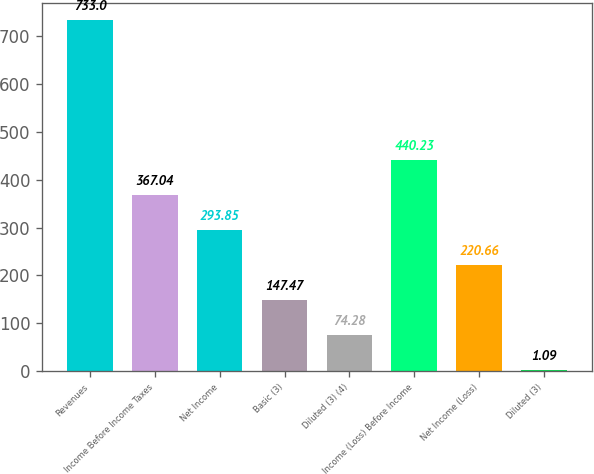Convert chart. <chart><loc_0><loc_0><loc_500><loc_500><bar_chart><fcel>Revenues<fcel>Income Before Income Taxes<fcel>Net Income<fcel>Basic (3)<fcel>Diluted (3) (4)<fcel>Income (Loss) Before Income<fcel>Net Income (Loss)<fcel>Diluted (3)<nl><fcel>733<fcel>367.04<fcel>293.85<fcel>147.47<fcel>74.28<fcel>440.23<fcel>220.66<fcel>1.09<nl></chart> 